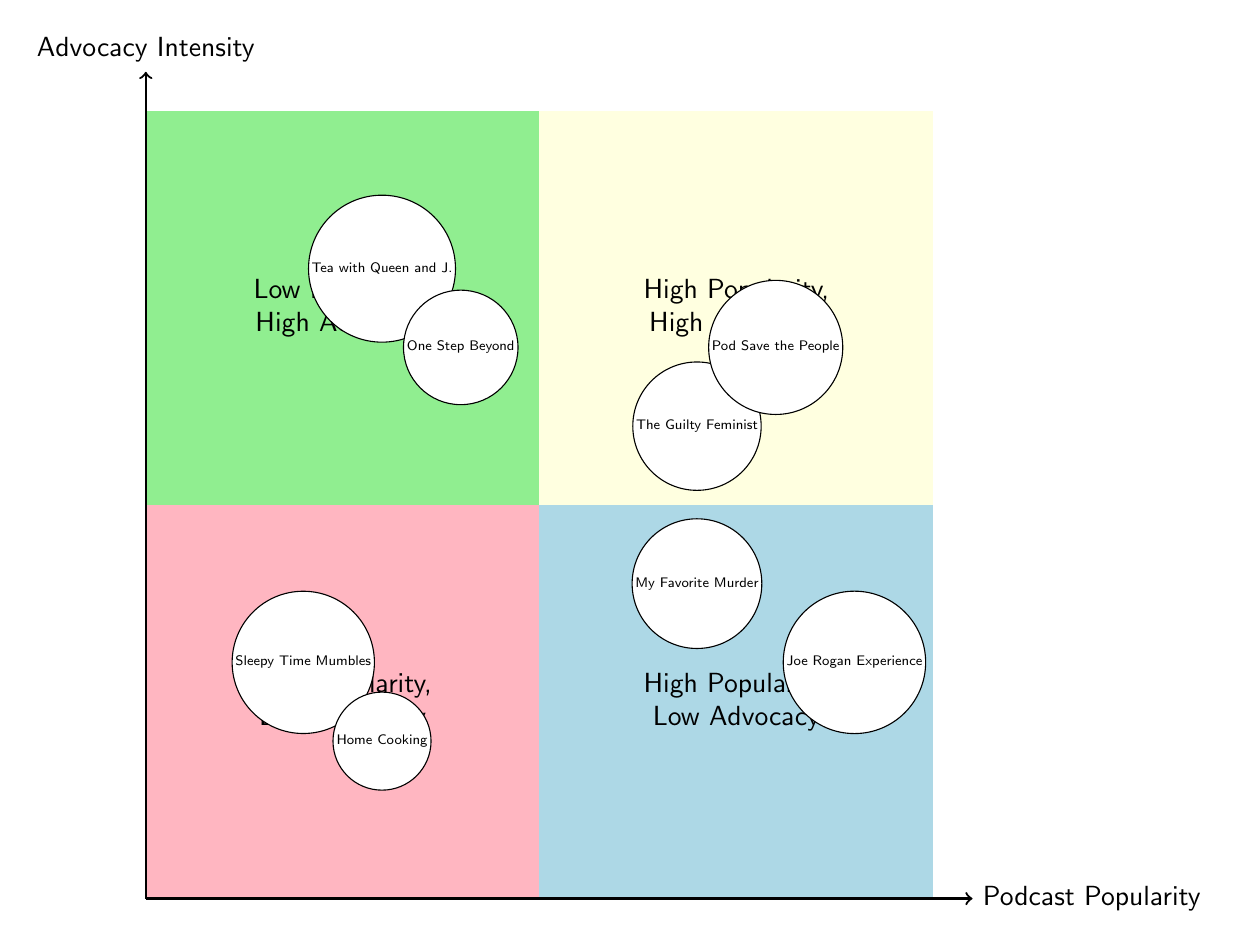Which podcast has the highest advocacy intensity? The highest advocacy intensity is represented in the "High Popularity, High Advocacy" quadrant, where the podcasts "The Guilty Feminist" and "Pod Save the People" are located. Among these, "The Guilty Feminist" is listed first, suggesting it is the example used for highest intensity.
Answer: The Guilty Feminist How many podcasts are there in the "Low Popularity, High Advocacy" quadrant? In the "Low Popularity, High Advocacy" quadrant, there are two podcasts mentioned: "Tea with Queen and J." and "One Step Beyond." Therefore, the count is simply how many examples are listed in that quadrant.
Answer: 2 What is the advocacy theme of "My Favorite Murder"? "My Favorite Murder" is plotted in the quadrant of "High Popularity, Low Advocacy." The label indicates that its advocacy theme focuses on "Crime Awareness," which is written next to the podcast.
Answer: Crime Awareness Which genre is represented in the "High Popularity, High Advocacy" quadrant? The "High Popularity, High Advocacy" quadrant includes two podcasts, one being "The Guilty Feminist," which is categorized under the genre "Comedy." The other podcast, "Pod Save the People," falls under "News & Politics," both representative of different genres.
Answer: Comedy Which quadrant contains "Sleepy Time Mumbles"? "Sleepy Time Mumbles" is positioned in the "Low Popularity, Low Advocacy" quadrant, which indicates it has minimal popularity and advocacy intensity. This positioning can be verified by its location on the diagram, specifically in the lower left area.
Answer: Low Popularity, Low Advocacy Which podcast has the lowest popularity in the diagram? "Sleepy Time Mumbles" and "Home Cooking" are both in the "Low Popularity, Low Advocacy" quadrant. Therefore, they represent the lowest popularity according to their placement. However, "Sleepy Time Mumbles" is listed before "Home Cooking," implying it is the first example cited for low popularity.
Answer: Sleepy Time Mumbles What advocacy theme is associated with "One Step Beyond"? "One Step Beyond" is located in the "Low Popularity, High Advocacy" quadrant. The advocacy theme associated with it, as indicated next to the podcast name, is "Environmental Justice," showing its focus on a specific area of advocacy despite its lower popularity.
Answer: Environmental Justice How many total quadrants are shown in the diagram? The diagram is structured into four distinct quadrants for analysis: "High Popularity, High Advocacy," "High Popularity, Low Advocacy," "Low Popularity, High Advocacy," and "Low Popularity, Low Advocacy." Counting these gives a total number of quadrants.
Answer: 4 